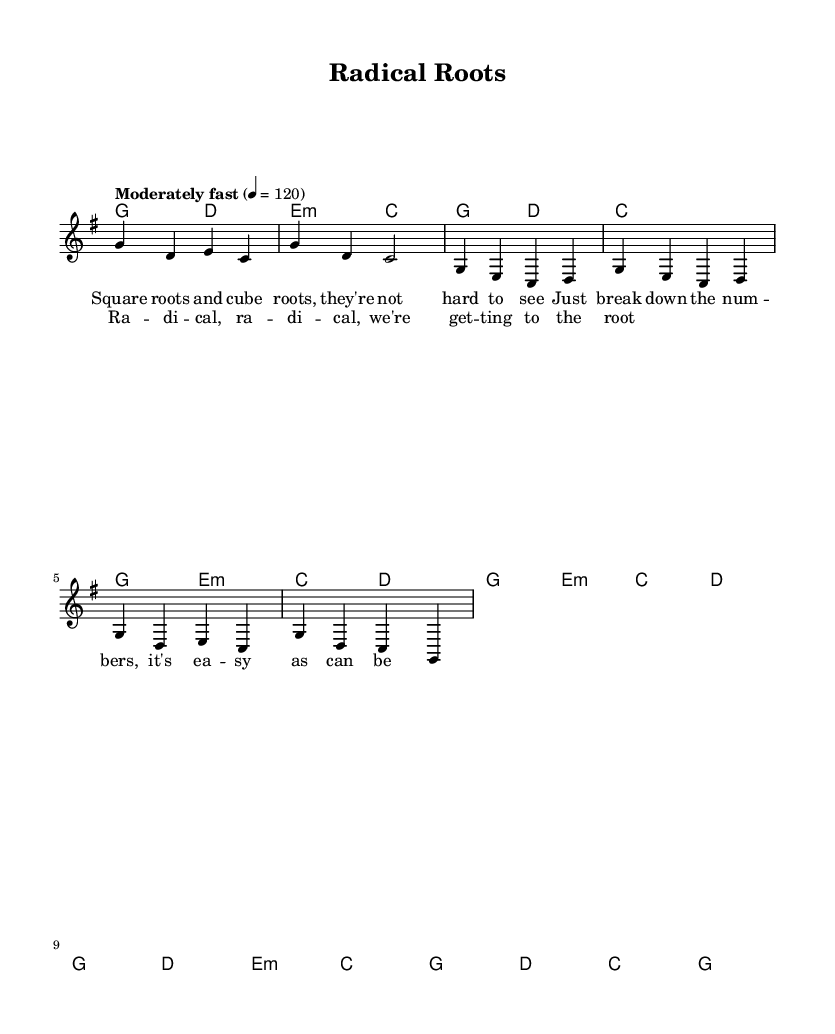What is the key signature of this music? The key signature shown at the beginning of the score is G major, which has one sharp (F sharp).
Answer: G major What is the time signature of this music? The time signature found at the beginning of the score is 4/4, indicating four beats per measure.
Answer: 4/4 What is the tempo marking of this piece? The tempo marking states "Moderately fast" with a metronome marking of quarter note equals 120 beats per minute.
Answer: Moderately fast How many measures are in the chorus section? Counting the measures in the chorus, there are 4 measures shown in the music, specifically those containing the lyrics "Radical, radical..."
Answer: 4 What kind of chords appear in the intro? The chords listed in the intro section are G major and D major followed by E minor and C major.
Answer: G major and D major Why is this piece categorized as educational rock music? The lyrics focus on explaining mathematical concepts like square roots and cube roots, making it educational in nature while maintaining a rock music style.
Answer: Educational and math-focused What is the final chord of the piece? The final chord shown in the score is a C major chord, which concludes the musical piece.
Answer: C major 